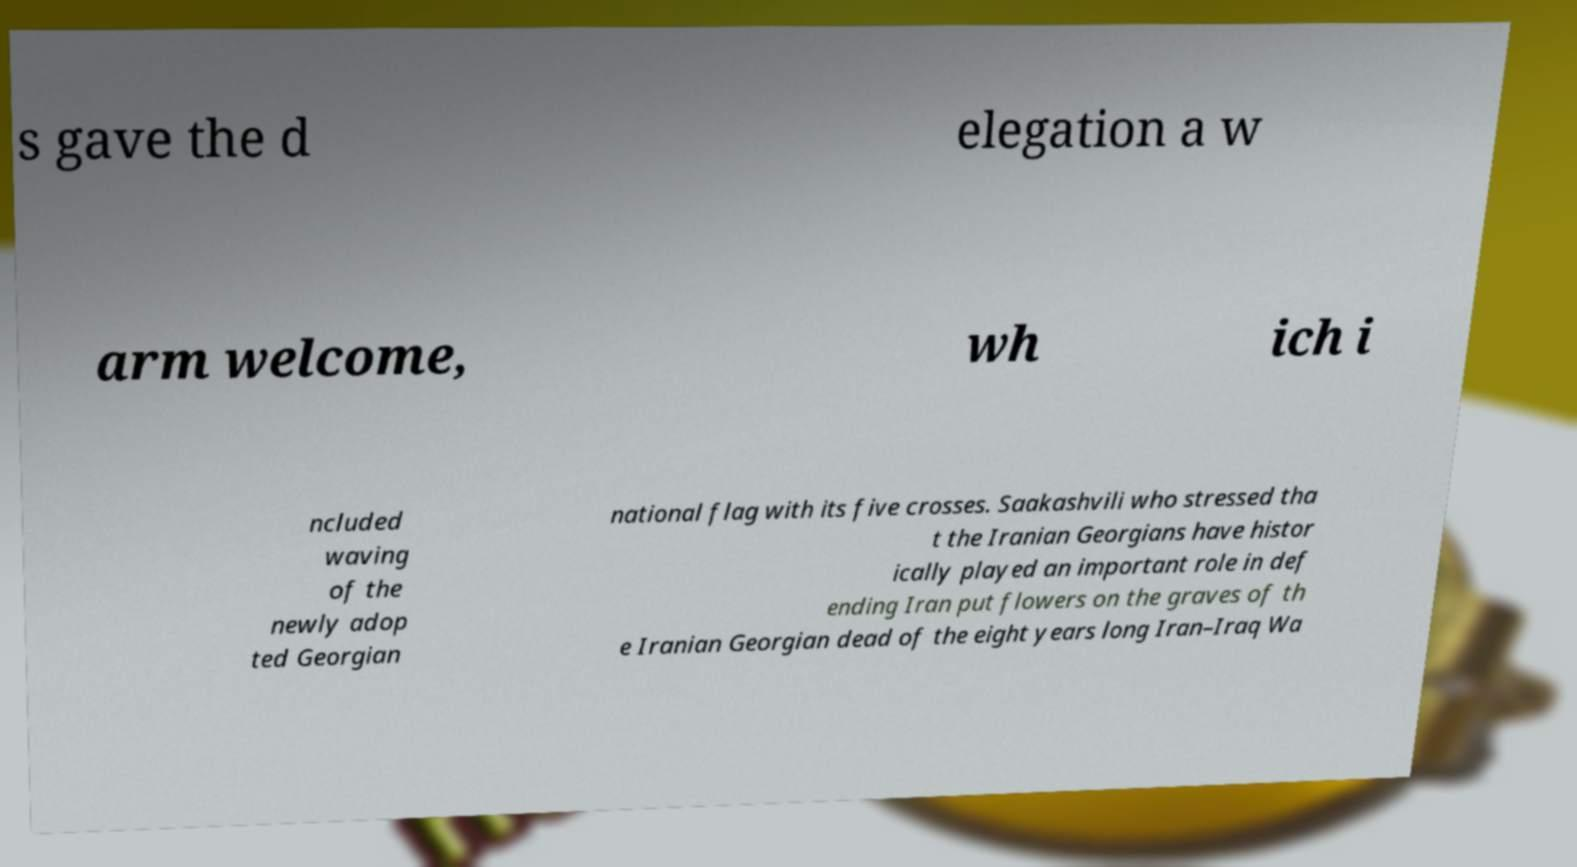Please identify and transcribe the text found in this image. s gave the d elegation a w arm welcome, wh ich i ncluded waving of the newly adop ted Georgian national flag with its five crosses. Saakashvili who stressed tha t the Iranian Georgians have histor ically played an important role in def ending Iran put flowers on the graves of th e Iranian Georgian dead of the eight years long Iran–Iraq Wa 